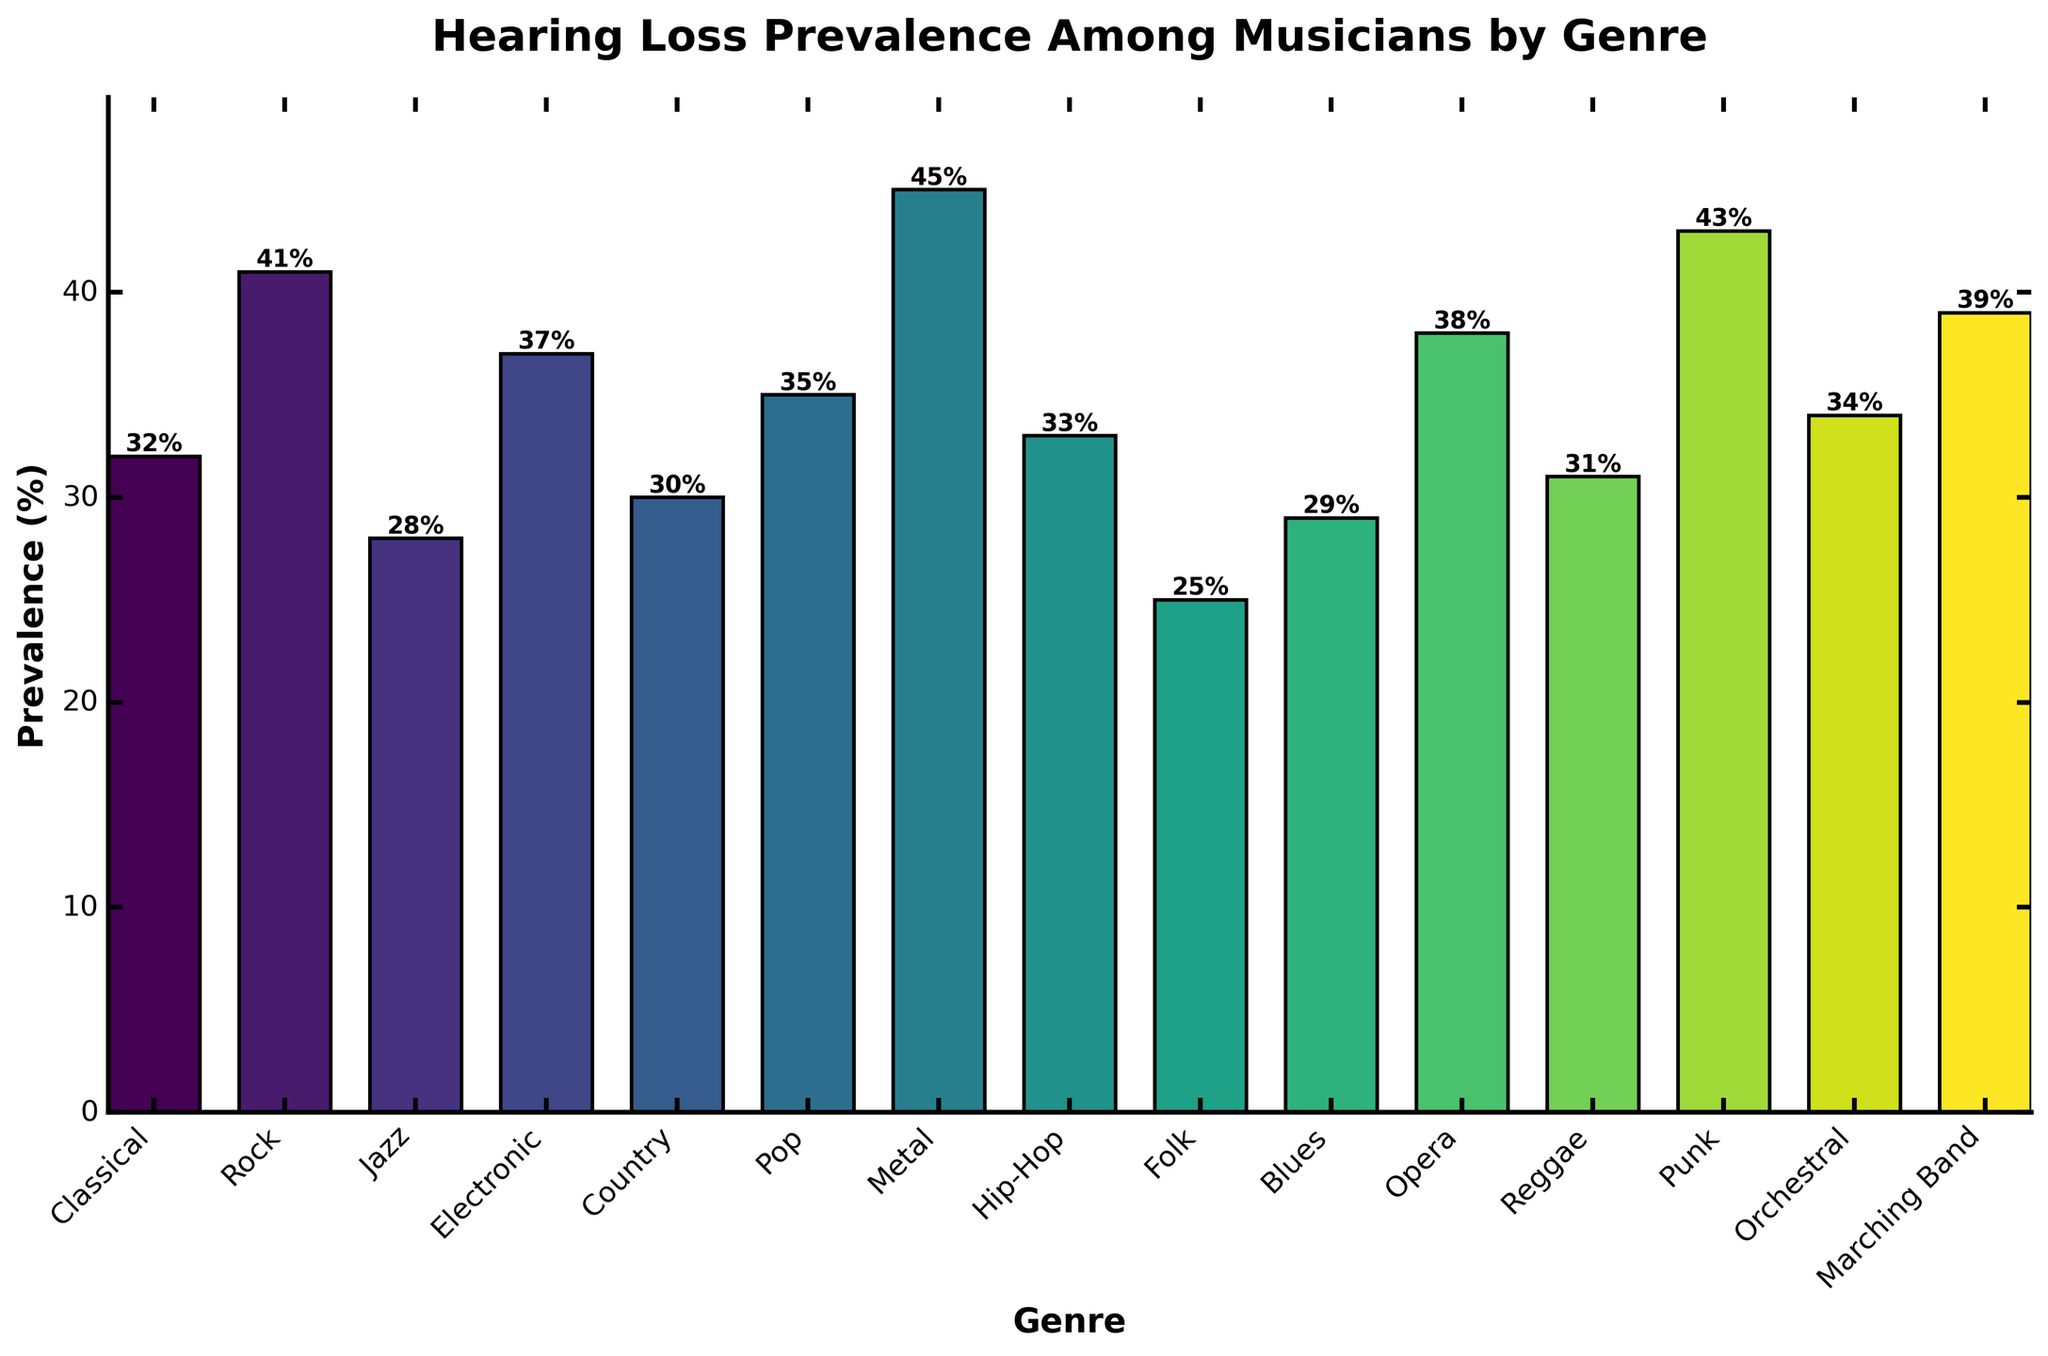Which genre has the highest hearing loss prevalence? The bar representing the Metal genre has the highest value at 45%, which is more than any other genre in the figure.
Answer: Metal Which genre has the lowest hearing loss prevalence? The bar representing the Folk genre has the lowest value at 25%, which is less than any other genre in the figure.
Answer: Folk What's the difference in hearing loss prevalence between Rock and Jazz genres? The prevalence for Rock is 41%, and for Jazz, it is 28%. The difference calculated as 41% – 28% = 13%.
Answer: 13% Which genres have a hearing loss prevalence greater than 35%? By observing the bars, the genres Metal (45%), Punk (43%), Rock (41%), Marching Band (39%), Opera (38%), and Electronic (37%) each have a prevalence greater than 35%.
Answer: Metal, Punk, Rock, Marching Band, Opera, Electronic What is the average hearing loss prevalence among the genres Classical, Country, and Blues? The prevalences are 32%, 30%, and 29%, respectively. Summing these values yields 32 + 30 + 29 = 91. Dividing by 3 gives an average of 91 / 3 = 30.33%.
Answer: 30.33% Which genre has a greater prevalence, Hip-Hop or Pop? By comparing the bars, Hip-Hop has 33% and Pop has 35%. Therefore, Pop has a greater prevalence.
Answer: Pop What are the visual indicators that differentiate the genre with the highest prevalence from the others? The Metal genre's bar is the tallest, indicating the highest prevalence. It also has a numerical label of 45% on top, which is higher than any other bar.
Answer: Tallest bar, 45% How many genres have a prevalence below 30%? By counting the bars with values below 30%, we find Jazz (28%) and Folk (25%), making a total of 2 genres.
Answer: 2 What is the median hearing loss prevalence among all the genres listed? Sorting all the prevalence values: 25%, 28%, 29%, 30%, 31%, 32%, 33%, 34%, 35%, 37%, 38%, 39%, 41%, 43%, 45%. The median value, being the middle of the data set, is the 8th value: 34%.
Answer: 34% What is the sum of the hearing loss prevalence percentages for Electronic, Opera, and Marching Band? Electronic has 37%, Opera has 38%, and Marching Band has 39%. Summing these values gives 37 + 38 + 39 = 114%.
Answer: 114% 